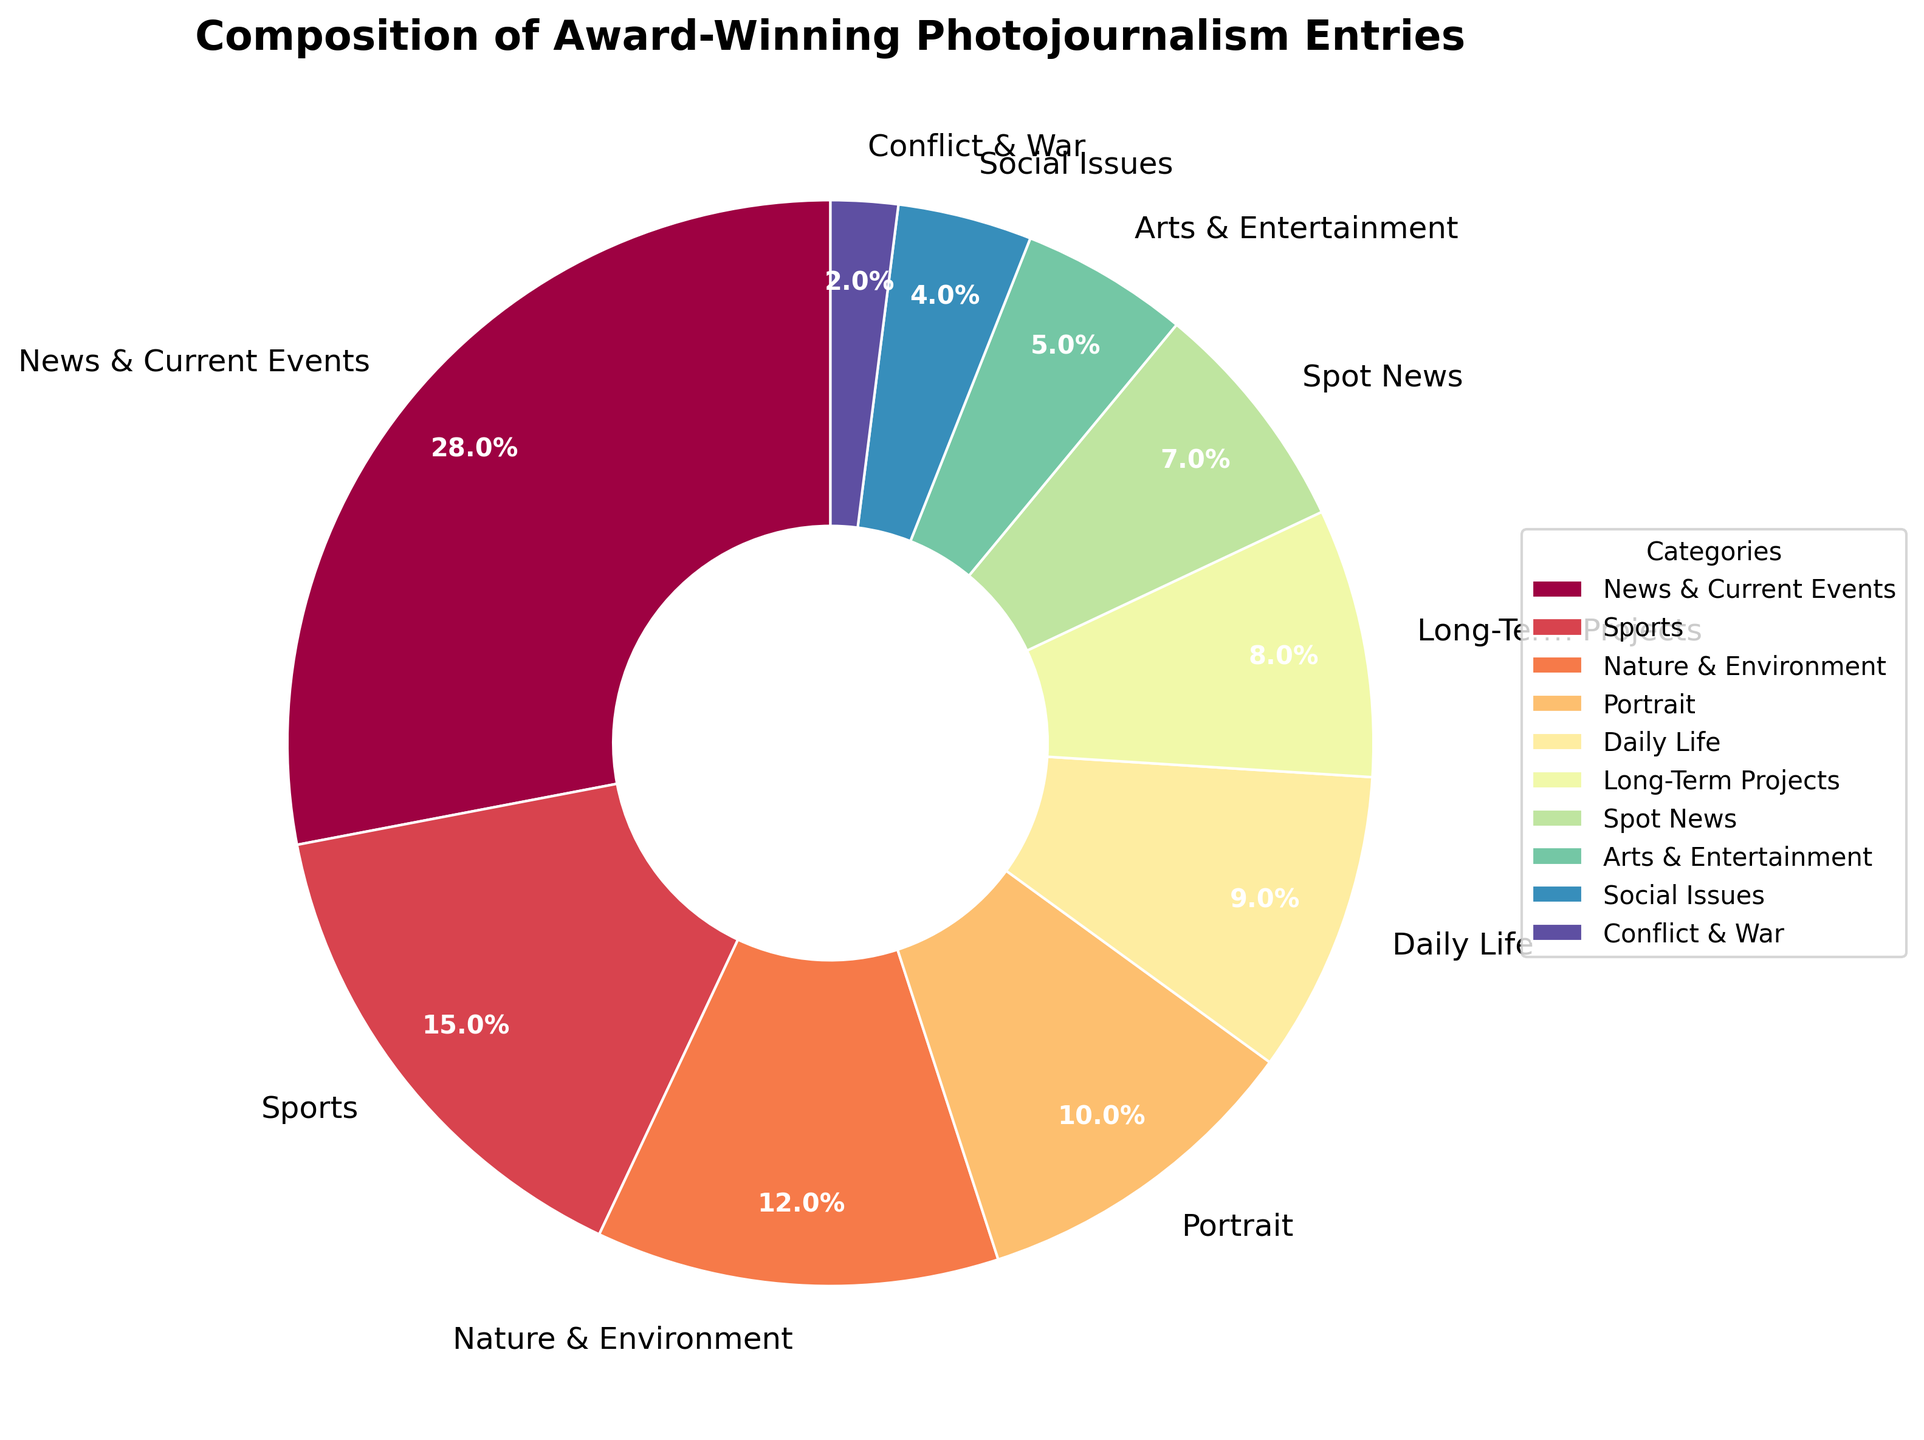Which category has the highest percentage of award-winning entries? By inspecting the pie chart, the category with the largest slice should be identified. The largest slice appears to correspond to "News & Current Events" with a percentage of 28%.
Answer: News & Current Events What is the combined percentage for the top three categories? Sum the percentages of the top three categories: "News & Current Events" (28%), "Sports" (15%), and "Nature & Environment" (12%). The total is 28 + 15 + 12 = 55%.
Answer: 55% How does the percentage of "Portrait" compare to "Daily Life"? Find "Portrait" in the chart, which has 10%, and "Daily Life," which has 9%. Compare the two percentages: 10% is greater than 9%.
Answer: Portrait is greater than Daily Life Which categories have percentages less than 10%? Identify slices with percentages below 10%. These are: "Daily Life" (9%), "Long-Term Projects" (8%), "Spot News" (7%), "Arts & Entertainment" (5%), "Social Issues" (4%), and "Conflict & War" (2%).
Answer: Daily Life, Long-Term Projects, Spot News, Arts & Entertainment, Social Issues, Conflict & War What is the percentage difference between "Sports" and "Spot News"? Subtract the "Spot News" percentage from "Sports": 15% - 7% = 8%.
Answer: 8% Which category has the smallest representation in the chart and what is its percentage? Identify the smallest slice in the pie chart which is "Conflict & War," corresponding to 2%.
Answer: Conflict & War at 2% What is the combined percentage of "Social Issues" and "Conflict & War"? Sum the percentages of "Social Issues" (4%) and "Conflict & War" (2%): 4 + 2 = 6%.
Answer: 6% How does the percentage of "Nature & Environment" compare to the average percentage of all categories? Calculate the average percentage: (28 + 15 + 12 + 10 + 9 + 8 + 7 + 5 + 4 + 2)/10 = 10%. Compare "Nature & Environment" (12%) to the average (10%): 12% is greater than 10%.
Answer: Nature & Environment is greater than the average Which section has the darker color in the pie chart, "Arts & Entertainment" or "Conflict & War"? Visually inspect the pie chart colors, and determine that "Conflict & War" is drawn with a relatively darker color compared to "Arts & Entertainment".
Answer: Conflict & War What percentage of the entries fall into the "News & Current Events" and "Sports" categories combined? Sum the percentages of "News & Current Events" (28%) and "Sports" (15%): 28 + 15 = 43%.
Answer: 43% 